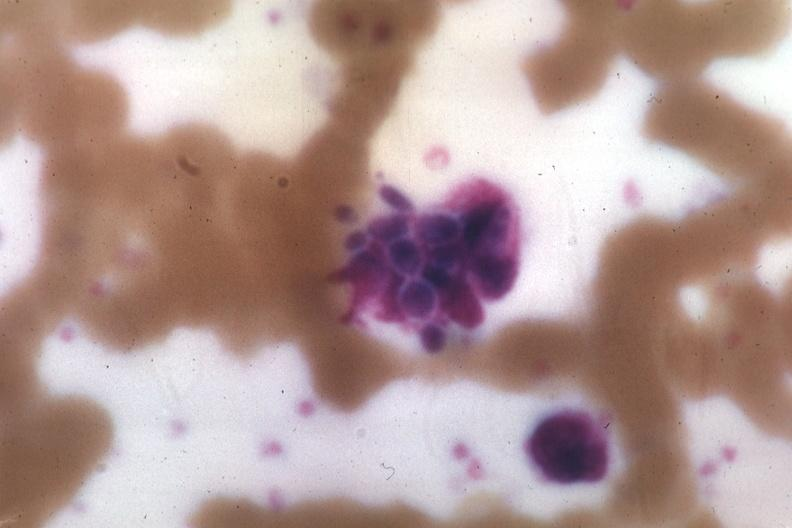what is present?
Answer the question using a single word or phrase. Blood 